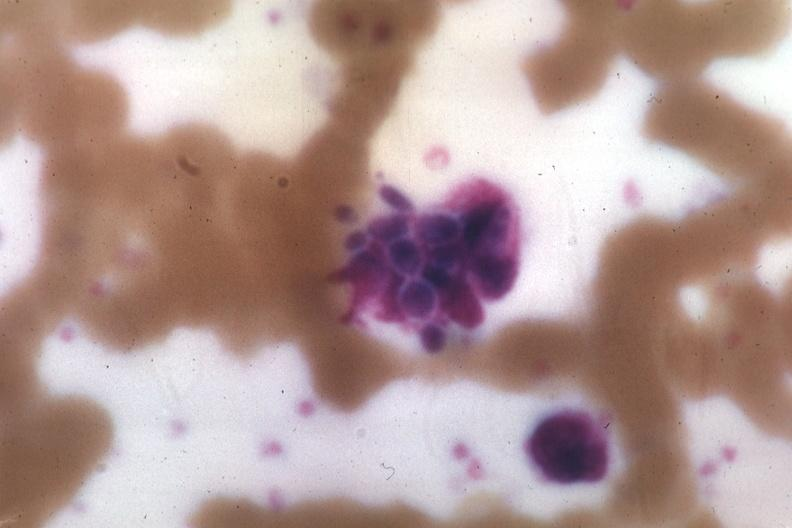what is present?
Answer the question using a single word or phrase. Blood 